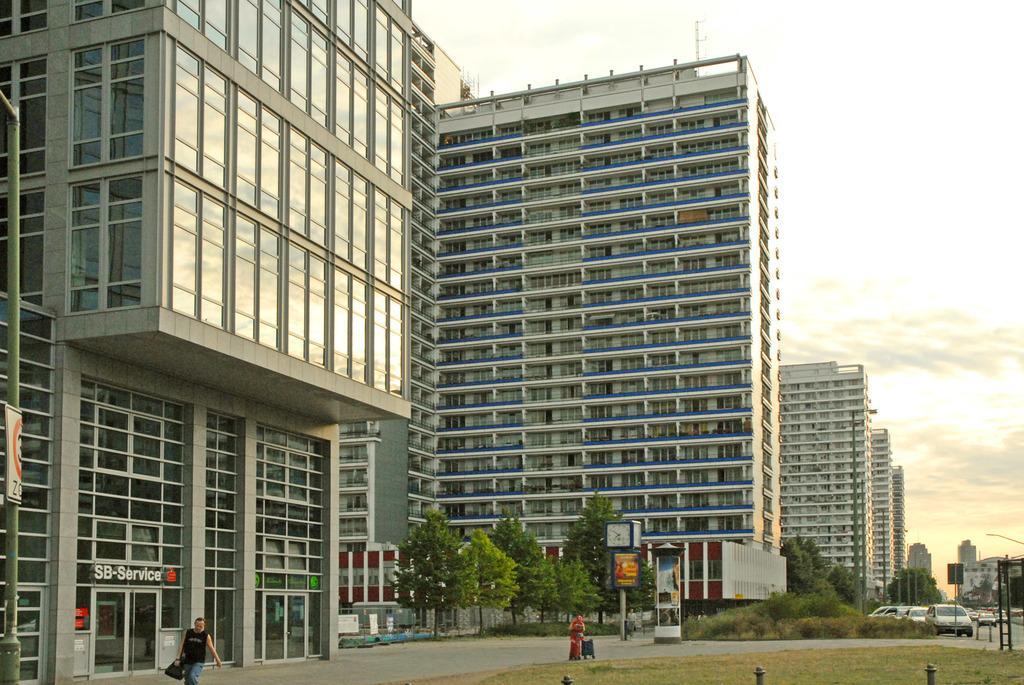How would you summarize this image in a sentence or two? This image is taken outdoors. At the bottom of the image there is a road and a ground with grass on it. At the top of the image there is a sky with clouds. In the background there are many buildings with walls, windows, doors, balconies and roofs. There are a few trees and plants. A few cars are parked on the road and a few are moving on the road. There are a few sign boards. A man is walking on the road 